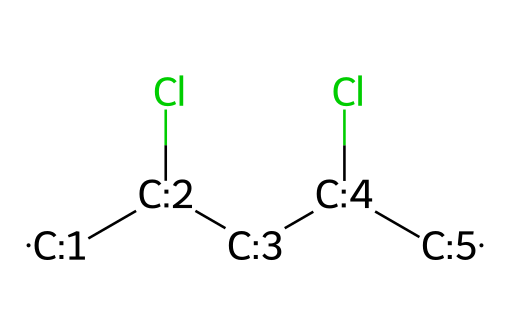What is the main component of this chemical? The SMILES representation reveals that this molecule is composed primarily of carbon (C) and chlorine (Cl) atoms, indicating that polyvinyl chloride is the main component.
Answer: polyvinyl chloride How many chlorine atoms are present in this structure? The SMILES notation indicates two chlorine (Cl) atoms in the chemical structure, which is confirmed by counting the "Cl" entries within the representation.
Answer: 2 What is the total number of carbon atoms in the structure? By examining the SMILES notation, we can identify a total of four carbon (C) atoms represented in the chain, as each [CH] group represents a carbon atom.
Answer: 4 Does this chemical exhibit any double bonds? The SMILES representation does not show any double bonds between carbon atoms, as there are no '=' symbols present. This indicates it has only single bonds.
Answer: no What type of bonds are present in the polyvinyl chloride structure? The molecule's structure consists entirely of single bonds, which is indicated by the absence of double or triple bond notations in the SMILES representation.
Answer: single bonds What property do the chlorine atoms impart to this chemical? The presence of chlorine atoms in the structure affects the chemical's polarity, making it more polar and giving it unique properties like resistance to combustibility.
Answer: increased polarity How does the chlorine content affect the solubility of this chemical? The chlorine content contributes to the hydrophobic character, which reduces the solubility of polyvinyl chloride in water while enhancing solubility in organic solvents.
Answer: reduced solubility in water 